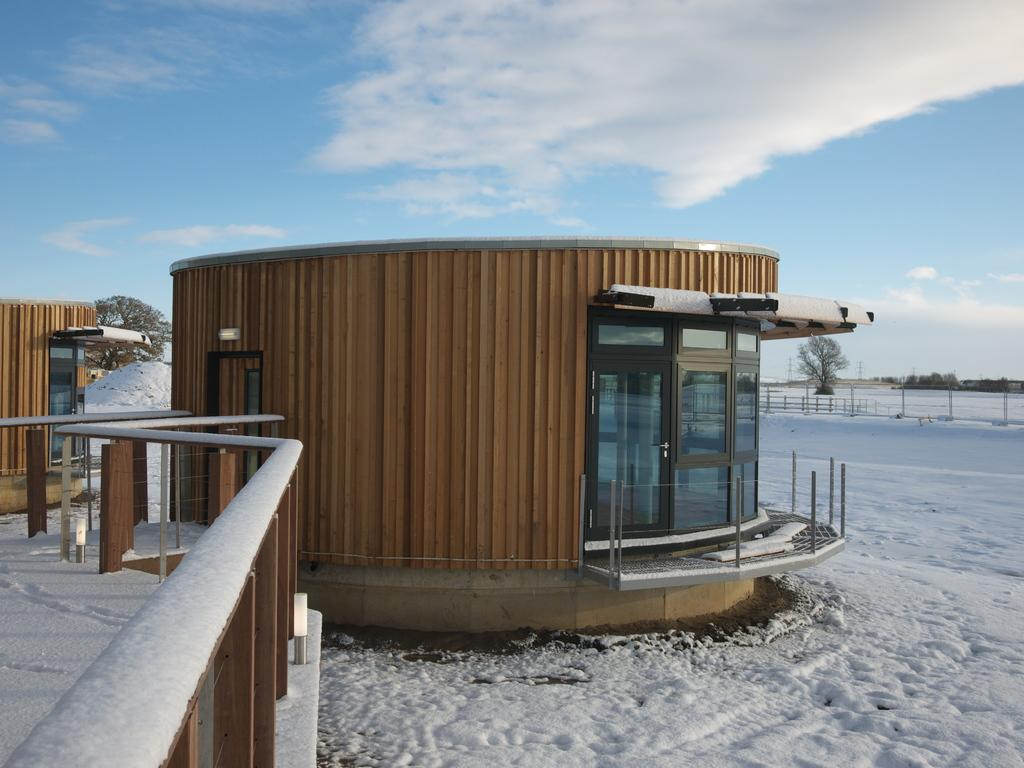What type of structure is visible in the image? There is a house in the image. What other objects can be seen in the image? There are poles, trees, a fence, and doors visible in the image. What is the weather like in the image? There is snow in the image, indicating a cold or wintery weather. What is visible in the background of the image? The sky is visible in the background of the image. What type of jelly is being used to decorate the house in the image? There is no jelly present in the image; it is a house with snow and other objects. Can you tell me what the stranger's wish is in the image? There is no stranger or any indication of a wish in the image. 